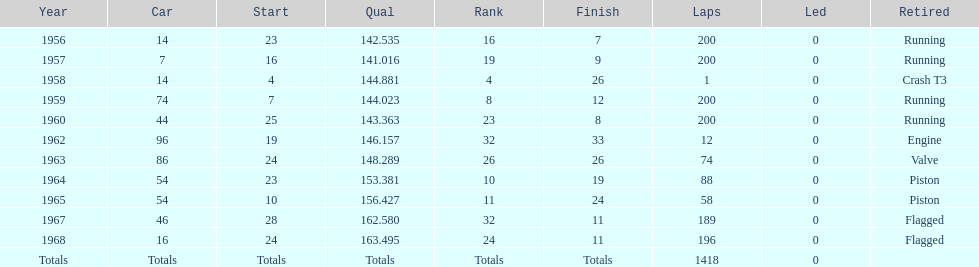Indicate the number of moments he concluded over 10th rank. 3. 